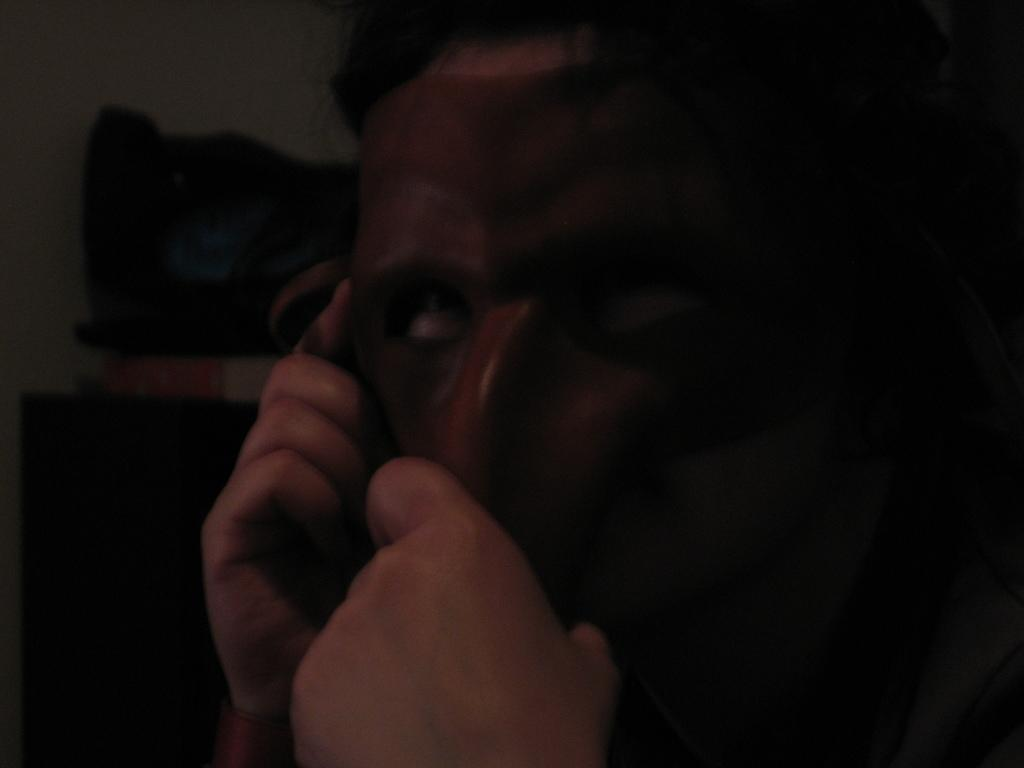Who or what is the main subject of the image? There is a person in the image. What is the person wearing on their face? The person is wearing a mask on their face. Can you describe the background of the image? The background of the image is blurry. What language is the person speaking in the image? The image does not provide any information about the language the person is speaking. 